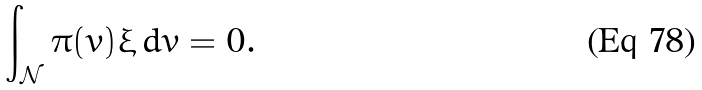Convert formula to latex. <formula><loc_0><loc_0><loc_500><loc_500>\int _ { \mathcal { N } } \pi ( v ) \xi \, d v = 0 .</formula> 